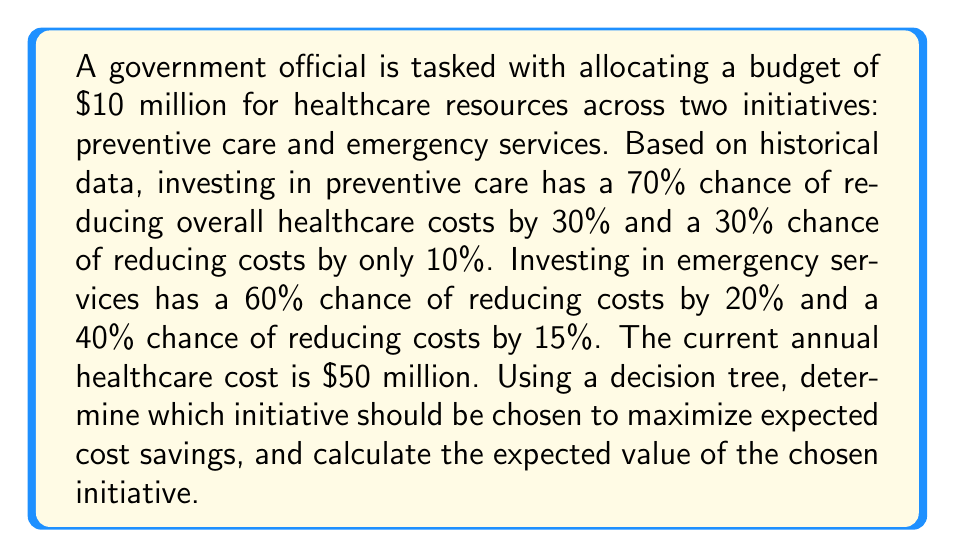What is the answer to this math problem? Let's approach this problem using a decision tree:

1. First, we'll calculate the expected value (EV) for each initiative:

   Preventive Care:
   $$EV_{preventive} = 0.70 \times (0.30 \times 50,000,000) + 0.30 \times (0.10 \times 50,000,000)$$
   $$EV_{preventive} = 0.70 \times 15,000,000 + 0.30 \times 5,000,000$$
   $$EV_{preventive} = 10,500,000 + 1,500,000 = 12,000,000$$

   Emergency Services:
   $$EV_{emergency} = 0.60 \times (0.20 \times 50,000,000) + 0.40 \times (0.15 \times 50,000,000)$$
   $$EV_{emergency} = 0.60 \times 10,000,000 + 0.40 \times 7,500,000$$
   $$EV_{emergency} = 6,000,000 + 3,000,000 = 9,000,000$$

2. Compare the expected values:
   Preventive Care has a higher expected value of cost savings ($12 million) compared to Emergency Services ($9 million).

3. Calculate the net expected value by subtracting the initial investment:
   $$Net EV_{preventive} = 12,000,000 - 10,000,000 = 2,000,000$$

Therefore, the government official should choose to invest in preventive care to maximize expected cost savings.

[asy]
unitsize(1cm);

// Decision node
draw((0,0)--(1,1), arrow=Arrow());
draw((0,0)--(1,-1), arrow=Arrow());

// Chance nodes
draw((1,1)--(2,1.5), arrow=Arrow());
draw((1,1)--(2,0.5), arrow=Arrow());
draw((1,-1)--(2,-0.5), arrow=Arrow());
draw((1,-1)--(2,-1.5), arrow=Arrow());

// Labels
label("Preventive Care", (0.5,0.7), E);
label("Emergency Services", (0.5,-0.7), E);
label("70%", (1.5,1.4), N);
label("30%", (1.5,0.6), S);
label("60%", (1.5,-0.6), N);
label("40%", (1.5,-1.4), S);
label("$15M", (2.2,1.5), E);
label("$5M", (2.2,0.5), E);
label("$10M", (2.2,-0.5), E);
label("$7.5M", (2.2,-1.5), E);

// Decision node
dot((0,0));
// Chance nodes
dot((1,1));
dot((1,-1));
[/asy]
Answer: The government official should invest in preventive care, which has an expected net value of $2 million in cost savings. 